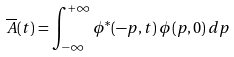<formula> <loc_0><loc_0><loc_500><loc_500>\overline { A } ( t ) = \int _ { - \infty } ^ { + \infty } \phi ^ { * } ( - p , t ) \, \phi ( p , 0 ) \, d p</formula> 